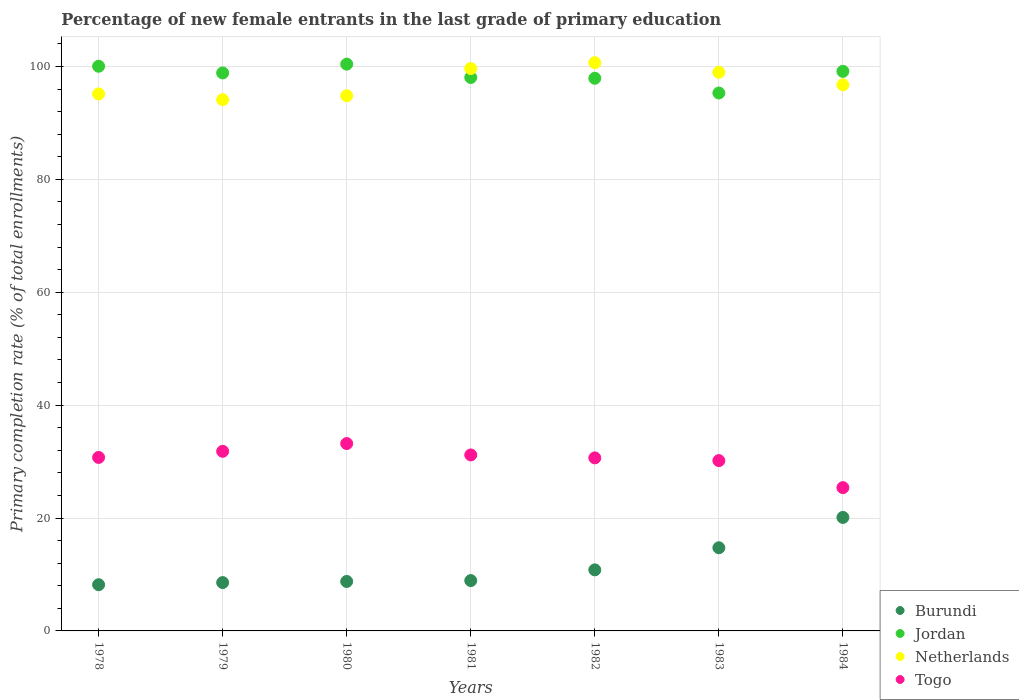What is the percentage of new female entrants in Togo in 1980?
Offer a very short reply. 33.19. Across all years, what is the maximum percentage of new female entrants in Jordan?
Your answer should be compact. 100.41. Across all years, what is the minimum percentage of new female entrants in Jordan?
Offer a terse response. 95.3. In which year was the percentage of new female entrants in Netherlands maximum?
Your answer should be compact. 1982. What is the total percentage of new female entrants in Netherlands in the graph?
Make the answer very short. 680.06. What is the difference between the percentage of new female entrants in Togo in 1978 and that in 1983?
Offer a terse response. 0.56. What is the difference between the percentage of new female entrants in Burundi in 1984 and the percentage of new female entrants in Netherlands in 1982?
Give a very brief answer. -80.56. What is the average percentage of new female entrants in Jordan per year?
Give a very brief answer. 98.53. In the year 1978, what is the difference between the percentage of new female entrants in Burundi and percentage of new female entrants in Jordan?
Your answer should be compact. -91.85. In how many years, is the percentage of new female entrants in Togo greater than 4 %?
Your answer should be very brief. 7. What is the ratio of the percentage of new female entrants in Burundi in 1979 to that in 1983?
Provide a succinct answer. 0.58. Is the difference between the percentage of new female entrants in Burundi in 1980 and 1983 greater than the difference between the percentage of new female entrants in Jordan in 1980 and 1983?
Your response must be concise. No. What is the difference between the highest and the second highest percentage of new female entrants in Netherlands?
Your answer should be compact. 1.04. What is the difference between the highest and the lowest percentage of new female entrants in Netherlands?
Your response must be concise. 6.56. In how many years, is the percentage of new female entrants in Jordan greater than the average percentage of new female entrants in Jordan taken over all years?
Your answer should be compact. 4. Is the sum of the percentage of new female entrants in Togo in 1981 and 1984 greater than the maximum percentage of new female entrants in Netherlands across all years?
Offer a terse response. No. Is the percentage of new female entrants in Netherlands strictly greater than the percentage of new female entrants in Togo over the years?
Offer a terse response. Yes. How many dotlines are there?
Your answer should be compact. 4. Are the values on the major ticks of Y-axis written in scientific E-notation?
Ensure brevity in your answer.  No. Does the graph contain any zero values?
Make the answer very short. No. Does the graph contain grids?
Give a very brief answer. Yes. Where does the legend appear in the graph?
Offer a very short reply. Bottom right. How many legend labels are there?
Provide a short and direct response. 4. What is the title of the graph?
Make the answer very short. Percentage of new female entrants in the last grade of primary education. What is the label or title of the X-axis?
Provide a succinct answer. Years. What is the label or title of the Y-axis?
Offer a terse response. Primary completion rate (% of total enrollments). What is the Primary completion rate (% of total enrollments) in Burundi in 1978?
Ensure brevity in your answer.  8.19. What is the Primary completion rate (% of total enrollments) of Jordan in 1978?
Make the answer very short. 100.04. What is the Primary completion rate (% of total enrollments) of Netherlands in 1978?
Keep it short and to the point. 95.13. What is the Primary completion rate (% of total enrollments) of Togo in 1978?
Your answer should be compact. 30.73. What is the Primary completion rate (% of total enrollments) in Burundi in 1979?
Offer a very short reply. 8.57. What is the Primary completion rate (% of total enrollments) of Jordan in 1979?
Make the answer very short. 98.85. What is the Primary completion rate (% of total enrollments) in Netherlands in 1979?
Offer a terse response. 94.11. What is the Primary completion rate (% of total enrollments) of Togo in 1979?
Your answer should be compact. 31.82. What is the Primary completion rate (% of total enrollments) in Burundi in 1980?
Make the answer very short. 8.76. What is the Primary completion rate (% of total enrollments) of Jordan in 1980?
Ensure brevity in your answer.  100.41. What is the Primary completion rate (% of total enrollments) of Netherlands in 1980?
Your answer should be compact. 94.81. What is the Primary completion rate (% of total enrollments) in Togo in 1980?
Make the answer very short. 33.19. What is the Primary completion rate (% of total enrollments) in Burundi in 1981?
Offer a very short reply. 8.92. What is the Primary completion rate (% of total enrollments) of Jordan in 1981?
Your answer should be compact. 98.05. What is the Primary completion rate (% of total enrollments) in Netherlands in 1981?
Keep it short and to the point. 99.63. What is the Primary completion rate (% of total enrollments) of Togo in 1981?
Provide a short and direct response. 31.18. What is the Primary completion rate (% of total enrollments) in Burundi in 1982?
Make the answer very short. 10.82. What is the Primary completion rate (% of total enrollments) in Jordan in 1982?
Your response must be concise. 97.91. What is the Primary completion rate (% of total enrollments) of Netherlands in 1982?
Provide a short and direct response. 100.67. What is the Primary completion rate (% of total enrollments) of Togo in 1982?
Your answer should be very brief. 30.66. What is the Primary completion rate (% of total enrollments) in Burundi in 1983?
Your response must be concise. 14.73. What is the Primary completion rate (% of total enrollments) of Jordan in 1983?
Ensure brevity in your answer.  95.3. What is the Primary completion rate (% of total enrollments) of Netherlands in 1983?
Keep it short and to the point. 98.96. What is the Primary completion rate (% of total enrollments) of Togo in 1983?
Keep it short and to the point. 30.17. What is the Primary completion rate (% of total enrollments) of Burundi in 1984?
Your answer should be very brief. 20.11. What is the Primary completion rate (% of total enrollments) of Jordan in 1984?
Provide a short and direct response. 99.13. What is the Primary completion rate (% of total enrollments) in Netherlands in 1984?
Ensure brevity in your answer.  96.75. What is the Primary completion rate (% of total enrollments) in Togo in 1984?
Make the answer very short. 25.39. Across all years, what is the maximum Primary completion rate (% of total enrollments) in Burundi?
Make the answer very short. 20.11. Across all years, what is the maximum Primary completion rate (% of total enrollments) of Jordan?
Provide a succinct answer. 100.41. Across all years, what is the maximum Primary completion rate (% of total enrollments) of Netherlands?
Make the answer very short. 100.67. Across all years, what is the maximum Primary completion rate (% of total enrollments) in Togo?
Your answer should be very brief. 33.19. Across all years, what is the minimum Primary completion rate (% of total enrollments) in Burundi?
Give a very brief answer. 8.19. Across all years, what is the minimum Primary completion rate (% of total enrollments) in Jordan?
Offer a terse response. 95.3. Across all years, what is the minimum Primary completion rate (% of total enrollments) of Netherlands?
Make the answer very short. 94.11. Across all years, what is the minimum Primary completion rate (% of total enrollments) in Togo?
Provide a short and direct response. 25.39. What is the total Primary completion rate (% of total enrollments) in Burundi in the graph?
Keep it short and to the point. 80.09. What is the total Primary completion rate (% of total enrollments) of Jordan in the graph?
Provide a short and direct response. 689.69. What is the total Primary completion rate (% of total enrollments) of Netherlands in the graph?
Ensure brevity in your answer.  680.06. What is the total Primary completion rate (% of total enrollments) of Togo in the graph?
Your answer should be compact. 213.14. What is the difference between the Primary completion rate (% of total enrollments) in Burundi in 1978 and that in 1979?
Make the answer very short. -0.38. What is the difference between the Primary completion rate (% of total enrollments) of Jordan in 1978 and that in 1979?
Your answer should be compact. 1.19. What is the difference between the Primary completion rate (% of total enrollments) in Netherlands in 1978 and that in 1979?
Keep it short and to the point. 1.02. What is the difference between the Primary completion rate (% of total enrollments) of Togo in 1978 and that in 1979?
Offer a terse response. -1.09. What is the difference between the Primary completion rate (% of total enrollments) of Burundi in 1978 and that in 1980?
Ensure brevity in your answer.  -0.58. What is the difference between the Primary completion rate (% of total enrollments) in Jordan in 1978 and that in 1980?
Provide a short and direct response. -0.37. What is the difference between the Primary completion rate (% of total enrollments) of Netherlands in 1978 and that in 1980?
Ensure brevity in your answer.  0.32. What is the difference between the Primary completion rate (% of total enrollments) of Togo in 1978 and that in 1980?
Give a very brief answer. -2.46. What is the difference between the Primary completion rate (% of total enrollments) in Burundi in 1978 and that in 1981?
Provide a short and direct response. -0.73. What is the difference between the Primary completion rate (% of total enrollments) in Jordan in 1978 and that in 1981?
Your response must be concise. 1.99. What is the difference between the Primary completion rate (% of total enrollments) of Netherlands in 1978 and that in 1981?
Offer a very short reply. -4.5. What is the difference between the Primary completion rate (% of total enrollments) of Togo in 1978 and that in 1981?
Provide a succinct answer. -0.44. What is the difference between the Primary completion rate (% of total enrollments) of Burundi in 1978 and that in 1982?
Your response must be concise. -2.63. What is the difference between the Primary completion rate (% of total enrollments) in Jordan in 1978 and that in 1982?
Ensure brevity in your answer.  2.13. What is the difference between the Primary completion rate (% of total enrollments) in Netherlands in 1978 and that in 1982?
Ensure brevity in your answer.  -5.54. What is the difference between the Primary completion rate (% of total enrollments) in Togo in 1978 and that in 1982?
Your answer should be very brief. 0.08. What is the difference between the Primary completion rate (% of total enrollments) in Burundi in 1978 and that in 1983?
Provide a succinct answer. -6.54. What is the difference between the Primary completion rate (% of total enrollments) of Jordan in 1978 and that in 1983?
Give a very brief answer. 4.74. What is the difference between the Primary completion rate (% of total enrollments) in Netherlands in 1978 and that in 1983?
Keep it short and to the point. -3.83. What is the difference between the Primary completion rate (% of total enrollments) of Togo in 1978 and that in 1983?
Your response must be concise. 0.56. What is the difference between the Primary completion rate (% of total enrollments) of Burundi in 1978 and that in 1984?
Keep it short and to the point. -11.92. What is the difference between the Primary completion rate (% of total enrollments) in Jordan in 1978 and that in 1984?
Offer a terse response. 0.9. What is the difference between the Primary completion rate (% of total enrollments) in Netherlands in 1978 and that in 1984?
Ensure brevity in your answer.  -1.62. What is the difference between the Primary completion rate (% of total enrollments) of Togo in 1978 and that in 1984?
Provide a succinct answer. 5.35. What is the difference between the Primary completion rate (% of total enrollments) in Burundi in 1979 and that in 1980?
Provide a succinct answer. -0.2. What is the difference between the Primary completion rate (% of total enrollments) in Jordan in 1979 and that in 1980?
Your answer should be very brief. -1.56. What is the difference between the Primary completion rate (% of total enrollments) of Netherlands in 1979 and that in 1980?
Offer a terse response. -0.7. What is the difference between the Primary completion rate (% of total enrollments) in Togo in 1979 and that in 1980?
Ensure brevity in your answer.  -1.37. What is the difference between the Primary completion rate (% of total enrollments) of Burundi in 1979 and that in 1981?
Keep it short and to the point. -0.35. What is the difference between the Primary completion rate (% of total enrollments) in Jordan in 1979 and that in 1981?
Make the answer very short. 0.81. What is the difference between the Primary completion rate (% of total enrollments) in Netherlands in 1979 and that in 1981?
Your answer should be compact. -5.52. What is the difference between the Primary completion rate (% of total enrollments) in Togo in 1979 and that in 1981?
Your answer should be compact. 0.64. What is the difference between the Primary completion rate (% of total enrollments) in Burundi in 1979 and that in 1982?
Keep it short and to the point. -2.25. What is the difference between the Primary completion rate (% of total enrollments) in Jordan in 1979 and that in 1982?
Give a very brief answer. 0.95. What is the difference between the Primary completion rate (% of total enrollments) in Netherlands in 1979 and that in 1982?
Ensure brevity in your answer.  -6.56. What is the difference between the Primary completion rate (% of total enrollments) of Togo in 1979 and that in 1982?
Offer a very short reply. 1.16. What is the difference between the Primary completion rate (% of total enrollments) in Burundi in 1979 and that in 1983?
Provide a short and direct response. -6.17. What is the difference between the Primary completion rate (% of total enrollments) in Jordan in 1979 and that in 1983?
Make the answer very short. 3.56. What is the difference between the Primary completion rate (% of total enrollments) in Netherlands in 1979 and that in 1983?
Provide a succinct answer. -4.85. What is the difference between the Primary completion rate (% of total enrollments) in Togo in 1979 and that in 1983?
Provide a succinct answer. 1.65. What is the difference between the Primary completion rate (% of total enrollments) in Burundi in 1979 and that in 1984?
Ensure brevity in your answer.  -11.54. What is the difference between the Primary completion rate (% of total enrollments) of Jordan in 1979 and that in 1984?
Offer a terse response. -0.28. What is the difference between the Primary completion rate (% of total enrollments) in Netherlands in 1979 and that in 1984?
Provide a succinct answer. -2.63. What is the difference between the Primary completion rate (% of total enrollments) of Togo in 1979 and that in 1984?
Offer a terse response. 6.44. What is the difference between the Primary completion rate (% of total enrollments) of Burundi in 1980 and that in 1981?
Keep it short and to the point. -0.15. What is the difference between the Primary completion rate (% of total enrollments) in Jordan in 1980 and that in 1981?
Ensure brevity in your answer.  2.37. What is the difference between the Primary completion rate (% of total enrollments) of Netherlands in 1980 and that in 1981?
Keep it short and to the point. -4.82. What is the difference between the Primary completion rate (% of total enrollments) of Togo in 1980 and that in 1981?
Your response must be concise. 2.02. What is the difference between the Primary completion rate (% of total enrollments) in Burundi in 1980 and that in 1982?
Give a very brief answer. -2.05. What is the difference between the Primary completion rate (% of total enrollments) in Jordan in 1980 and that in 1982?
Provide a short and direct response. 2.51. What is the difference between the Primary completion rate (% of total enrollments) in Netherlands in 1980 and that in 1982?
Ensure brevity in your answer.  -5.86. What is the difference between the Primary completion rate (% of total enrollments) in Togo in 1980 and that in 1982?
Offer a terse response. 2.54. What is the difference between the Primary completion rate (% of total enrollments) of Burundi in 1980 and that in 1983?
Ensure brevity in your answer.  -5.97. What is the difference between the Primary completion rate (% of total enrollments) in Jordan in 1980 and that in 1983?
Provide a succinct answer. 5.11. What is the difference between the Primary completion rate (% of total enrollments) of Netherlands in 1980 and that in 1983?
Your answer should be very brief. -4.15. What is the difference between the Primary completion rate (% of total enrollments) of Togo in 1980 and that in 1983?
Offer a terse response. 3.02. What is the difference between the Primary completion rate (% of total enrollments) in Burundi in 1980 and that in 1984?
Ensure brevity in your answer.  -11.34. What is the difference between the Primary completion rate (% of total enrollments) in Jordan in 1980 and that in 1984?
Provide a short and direct response. 1.28. What is the difference between the Primary completion rate (% of total enrollments) of Netherlands in 1980 and that in 1984?
Ensure brevity in your answer.  -1.93. What is the difference between the Primary completion rate (% of total enrollments) of Togo in 1980 and that in 1984?
Ensure brevity in your answer.  7.81. What is the difference between the Primary completion rate (% of total enrollments) of Burundi in 1981 and that in 1982?
Offer a very short reply. -1.9. What is the difference between the Primary completion rate (% of total enrollments) of Jordan in 1981 and that in 1982?
Offer a very short reply. 0.14. What is the difference between the Primary completion rate (% of total enrollments) in Netherlands in 1981 and that in 1982?
Offer a very short reply. -1.04. What is the difference between the Primary completion rate (% of total enrollments) of Togo in 1981 and that in 1982?
Your response must be concise. 0.52. What is the difference between the Primary completion rate (% of total enrollments) in Burundi in 1981 and that in 1983?
Your answer should be compact. -5.81. What is the difference between the Primary completion rate (% of total enrollments) of Jordan in 1981 and that in 1983?
Ensure brevity in your answer.  2.75. What is the difference between the Primary completion rate (% of total enrollments) in Netherlands in 1981 and that in 1983?
Give a very brief answer. 0.67. What is the difference between the Primary completion rate (% of total enrollments) of Togo in 1981 and that in 1983?
Provide a short and direct response. 1. What is the difference between the Primary completion rate (% of total enrollments) in Burundi in 1981 and that in 1984?
Your response must be concise. -11.19. What is the difference between the Primary completion rate (% of total enrollments) of Jordan in 1981 and that in 1984?
Ensure brevity in your answer.  -1.09. What is the difference between the Primary completion rate (% of total enrollments) in Netherlands in 1981 and that in 1984?
Your answer should be compact. 2.88. What is the difference between the Primary completion rate (% of total enrollments) in Togo in 1981 and that in 1984?
Provide a succinct answer. 5.79. What is the difference between the Primary completion rate (% of total enrollments) of Burundi in 1982 and that in 1983?
Make the answer very short. -3.91. What is the difference between the Primary completion rate (% of total enrollments) of Jordan in 1982 and that in 1983?
Ensure brevity in your answer.  2.61. What is the difference between the Primary completion rate (% of total enrollments) of Netherlands in 1982 and that in 1983?
Your answer should be compact. 1.71. What is the difference between the Primary completion rate (% of total enrollments) of Togo in 1982 and that in 1983?
Provide a short and direct response. 0.48. What is the difference between the Primary completion rate (% of total enrollments) in Burundi in 1982 and that in 1984?
Your answer should be very brief. -9.29. What is the difference between the Primary completion rate (% of total enrollments) of Jordan in 1982 and that in 1984?
Provide a short and direct response. -1.23. What is the difference between the Primary completion rate (% of total enrollments) in Netherlands in 1982 and that in 1984?
Ensure brevity in your answer.  3.93. What is the difference between the Primary completion rate (% of total enrollments) in Togo in 1982 and that in 1984?
Ensure brevity in your answer.  5.27. What is the difference between the Primary completion rate (% of total enrollments) of Burundi in 1983 and that in 1984?
Your answer should be compact. -5.37. What is the difference between the Primary completion rate (% of total enrollments) in Jordan in 1983 and that in 1984?
Your answer should be compact. -3.84. What is the difference between the Primary completion rate (% of total enrollments) of Netherlands in 1983 and that in 1984?
Make the answer very short. 2.22. What is the difference between the Primary completion rate (% of total enrollments) of Togo in 1983 and that in 1984?
Your response must be concise. 4.79. What is the difference between the Primary completion rate (% of total enrollments) in Burundi in 1978 and the Primary completion rate (% of total enrollments) in Jordan in 1979?
Your answer should be very brief. -90.67. What is the difference between the Primary completion rate (% of total enrollments) in Burundi in 1978 and the Primary completion rate (% of total enrollments) in Netherlands in 1979?
Offer a very short reply. -85.93. What is the difference between the Primary completion rate (% of total enrollments) of Burundi in 1978 and the Primary completion rate (% of total enrollments) of Togo in 1979?
Keep it short and to the point. -23.63. What is the difference between the Primary completion rate (% of total enrollments) in Jordan in 1978 and the Primary completion rate (% of total enrollments) in Netherlands in 1979?
Provide a succinct answer. 5.92. What is the difference between the Primary completion rate (% of total enrollments) of Jordan in 1978 and the Primary completion rate (% of total enrollments) of Togo in 1979?
Give a very brief answer. 68.22. What is the difference between the Primary completion rate (% of total enrollments) of Netherlands in 1978 and the Primary completion rate (% of total enrollments) of Togo in 1979?
Give a very brief answer. 63.31. What is the difference between the Primary completion rate (% of total enrollments) in Burundi in 1978 and the Primary completion rate (% of total enrollments) in Jordan in 1980?
Ensure brevity in your answer.  -92.23. What is the difference between the Primary completion rate (% of total enrollments) of Burundi in 1978 and the Primary completion rate (% of total enrollments) of Netherlands in 1980?
Make the answer very short. -86.62. What is the difference between the Primary completion rate (% of total enrollments) of Burundi in 1978 and the Primary completion rate (% of total enrollments) of Togo in 1980?
Your answer should be compact. -25.01. What is the difference between the Primary completion rate (% of total enrollments) in Jordan in 1978 and the Primary completion rate (% of total enrollments) in Netherlands in 1980?
Offer a very short reply. 5.23. What is the difference between the Primary completion rate (% of total enrollments) in Jordan in 1978 and the Primary completion rate (% of total enrollments) in Togo in 1980?
Ensure brevity in your answer.  66.84. What is the difference between the Primary completion rate (% of total enrollments) of Netherlands in 1978 and the Primary completion rate (% of total enrollments) of Togo in 1980?
Ensure brevity in your answer.  61.94. What is the difference between the Primary completion rate (% of total enrollments) in Burundi in 1978 and the Primary completion rate (% of total enrollments) in Jordan in 1981?
Your response must be concise. -89.86. What is the difference between the Primary completion rate (% of total enrollments) of Burundi in 1978 and the Primary completion rate (% of total enrollments) of Netherlands in 1981?
Give a very brief answer. -91.44. What is the difference between the Primary completion rate (% of total enrollments) in Burundi in 1978 and the Primary completion rate (% of total enrollments) in Togo in 1981?
Provide a short and direct response. -22.99. What is the difference between the Primary completion rate (% of total enrollments) in Jordan in 1978 and the Primary completion rate (% of total enrollments) in Netherlands in 1981?
Provide a succinct answer. 0.41. What is the difference between the Primary completion rate (% of total enrollments) in Jordan in 1978 and the Primary completion rate (% of total enrollments) in Togo in 1981?
Your answer should be compact. 68.86. What is the difference between the Primary completion rate (% of total enrollments) of Netherlands in 1978 and the Primary completion rate (% of total enrollments) of Togo in 1981?
Your response must be concise. 63.95. What is the difference between the Primary completion rate (% of total enrollments) in Burundi in 1978 and the Primary completion rate (% of total enrollments) in Jordan in 1982?
Ensure brevity in your answer.  -89.72. What is the difference between the Primary completion rate (% of total enrollments) of Burundi in 1978 and the Primary completion rate (% of total enrollments) of Netherlands in 1982?
Keep it short and to the point. -92.48. What is the difference between the Primary completion rate (% of total enrollments) in Burundi in 1978 and the Primary completion rate (% of total enrollments) in Togo in 1982?
Keep it short and to the point. -22.47. What is the difference between the Primary completion rate (% of total enrollments) of Jordan in 1978 and the Primary completion rate (% of total enrollments) of Netherlands in 1982?
Provide a succinct answer. -0.63. What is the difference between the Primary completion rate (% of total enrollments) of Jordan in 1978 and the Primary completion rate (% of total enrollments) of Togo in 1982?
Offer a terse response. 69.38. What is the difference between the Primary completion rate (% of total enrollments) in Netherlands in 1978 and the Primary completion rate (% of total enrollments) in Togo in 1982?
Your answer should be compact. 64.47. What is the difference between the Primary completion rate (% of total enrollments) in Burundi in 1978 and the Primary completion rate (% of total enrollments) in Jordan in 1983?
Your response must be concise. -87.11. What is the difference between the Primary completion rate (% of total enrollments) in Burundi in 1978 and the Primary completion rate (% of total enrollments) in Netherlands in 1983?
Provide a short and direct response. -90.78. What is the difference between the Primary completion rate (% of total enrollments) in Burundi in 1978 and the Primary completion rate (% of total enrollments) in Togo in 1983?
Give a very brief answer. -21.99. What is the difference between the Primary completion rate (% of total enrollments) in Jordan in 1978 and the Primary completion rate (% of total enrollments) in Netherlands in 1983?
Your response must be concise. 1.07. What is the difference between the Primary completion rate (% of total enrollments) of Jordan in 1978 and the Primary completion rate (% of total enrollments) of Togo in 1983?
Your response must be concise. 69.86. What is the difference between the Primary completion rate (% of total enrollments) in Netherlands in 1978 and the Primary completion rate (% of total enrollments) in Togo in 1983?
Provide a short and direct response. 64.96. What is the difference between the Primary completion rate (% of total enrollments) of Burundi in 1978 and the Primary completion rate (% of total enrollments) of Jordan in 1984?
Your answer should be compact. -90.95. What is the difference between the Primary completion rate (% of total enrollments) of Burundi in 1978 and the Primary completion rate (% of total enrollments) of Netherlands in 1984?
Offer a terse response. -88.56. What is the difference between the Primary completion rate (% of total enrollments) in Burundi in 1978 and the Primary completion rate (% of total enrollments) in Togo in 1984?
Give a very brief answer. -17.2. What is the difference between the Primary completion rate (% of total enrollments) in Jordan in 1978 and the Primary completion rate (% of total enrollments) in Netherlands in 1984?
Your response must be concise. 3.29. What is the difference between the Primary completion rate (% of total enrollments) of Jordan in 1978 and the Primary completion rate (% of total enrollments) of Togo in 1984?
Your response must be concise. 74.65. What is the difference between the Primary completion rate (% of total enrollments) in Netherlands in 1978 and the Primary completion rate (% of total enrollments) in Togo in 1984?
Keep it short and to the point. 69.74. What is the difference between the Primary completion rate (% of total enrollments) in Burundi in 1979 and the Primary completion rate (% of total enrollments) in Jordan in 1980?
Your answer should be compact. -91.85. What is the difference between the Primary completion rate (% of total enrollments) of Burundi in 1979 and the Primary completion rate (% of total enrollments) of Netherlands in 1980?
Ensure brevity in your answer.  -86.25. What is the difference between the Primary completion rate (% of total enrollments) in Burundi in 1979 and the Primary completion rate (% of total enrollments) in Togo in 1980?
Offer a terse response. -24.63. What is the difference between the Primary completion rate (% of total enrollments) in Jordan in 1979 and the Primary completion rate (% of total enrollments) in Netherlands in 1980?
Ensure brevity in your answer.  4.04. What is the difference between the Primary completion rate (% of total enrollments) of Jordan in 1979 and the Primary completion rate (% of total enrollments) of Togo in 1980?
Offer a terse response. 65.66. What is the difference between the Primary completion rate (% of total enrollments) of Netherlands in 1979 and the Primary completion rate (% of total enrollments) of Togo in 1980?
Your answer should be very brief. 60.92. What is the difference between the Primary completion rate (% of total enrollments) in Burundi in 1979 and the Primary completion rate (% of total enrollments) in Jordan in 1981?
Provide a short and direct response. -89.48. What is the difference between the Primary completion rate (% of total enrollments) of Burundi in 1979 and the Primary completion rate (% of total enrollments) of Netherlands in 1981?
Provide a short and direct response. -91.06. What is the difference between the Primary completion rate (% of total enrollments) of Burundi in 1979 and the Primary completion rate (% of total enrollments) of Togo in 1981?
Make the answer very short. -22.61. What is the difference between the Primary completion rate (% of total enrollments) of Jordan in 1979 and the Primary completion rate (% of total enrollments) of Netherlands in 1981?
Offer a very short reply. -0.78. What is the difference between the Primary completion rate (% of total enrollments) in Jordan in 1979 and the Primary completion rate (% of total enrollments) in Togo in 1981?
Make the answer very short. 67.68. What is the difference between the Primary completion rate (% of total enrollments) of Netherlands in 1979 and the Primary completion rate (% of total enrollments) of Togo in 1981?
Provide a succinct answer. 62.94. What is the difference between the Primary completion rate (% of total enrollments) in Burundi in 1979 and the Primary completion rate (% of total enrollments) in Jordan in 1982?
Keep it short and to the point. -89.34. What is the difference between the Primary completion rate (% of total enrollments) in Burundi in 1979 and the Primary completion rate (% of total enrollments) in Netherlands in 1982?
Keep it short and to the point. -92.11. What is the difference between the Primary completion rate (% of total enrollments) in Burundi in 1979 and the Primary completion rate (% of total enrollments) in Togo in 1982?
Make the answer very short. -22.09. What is the difference between the Primary completion rate (% of total enrollments) in Jordan in 1979 and the Primary completion rate (% of total enrollments) in Netherlands in 1982?
Keep it short and to the point. -1.82. What is the difference between the Primary completion rate (% of total enrollments) in Jordan in 1979 and the Primary completion rate (% of total enrollments) in Togo in 1982?
Ensure brevity in your answer.  68.2. What is the difference between the Primary completion rate (% of total enrollments) in Netherlands in 1979 and the Primary completion rate (% of total enrollments) in Togo in 1982?
Make the answer very short. 63.46. What is the difference between the Primary completion rate (% of total enrollments) of Burundi in 1979 and the Primary completion rate (% of total enrollments) of Jordan in 1983?
Ensure brevity in your answer.  -86.73. What is the difference between the Primary completion rate (% of total enrollments) of Burundi in 1979 and the Primary completion rate (% of total enrollments) of Netherlands in 1983?
Ensure brevity in your answer.  -90.4. What is the difference between the Primary completion rate (% of total enrollments) of Burundi in 1979 and the Primary completion rate (% of total enrollments) of Togo in 1983?
Offer a terse response. -21.61. What is the difference between the Primary completion rate (% of total enrollments) of Jordan in 1979 and the Primary completion rate (% of total enrollments) of Netherlands in 1983?
Your response must be concise. -0.11. What is the difference between the Primary completion rate (% of total enrollments) in Jordan in 1979 and the Primary completion rate (% of total enrollments) in Togo in 1983?
Provide a succinct answer. 68.68. What is the difference between the Primary completion rate (% of total enrollments) of Netherlands in 1979 and the Primary completion rate (% of total enrollments) of Togo in 1983?
Make the answer very short. 63.94. What is the difference between the Primary completion rate (% of total enrollments) of Burundi in 1979 and the Primary completion rate (% of total enrollments) of Jordan in 1984?
Offer a very short reply. -90.57. What is the difference between the Primary completion rate (% of total enrollments) in Burundi in 1979 and the Primary completion rate (% of total enrollments) in Netherlands in 1984?
Provide a short and direct response. -88.18. What is the difference between the Primary completion rate (% of total enrollments) of Burundi in 1979 and the Primary completion rate (% of total enrollments) of Togo in 1984?
Provide a short and direct response. -16.82. What is the difference between the Primary completion rate (% of total enrollments) of Jordan in 1979 and the Primary completion rate (% of total enrollments) of Netherlands in 1984?
Offer a very short reply. 2.11. What is the difference between the Primary completion rate (% of total enrollments) of Jordan in 1979 and the Primary completion rate (% of total enrollments) of Togo in 1984?
Offer a terse response. 73.47. What is the difference between the Primary completion rate (% of total enrollments) in Netherlands in 1979 and the Primary completion rate (% of total enrollments) in Togo in 1984?
Offer a terse response. 68.73. What is the difference between the Primary completion rate (% of total enrollments) in Burundi in 1980 and the Primary completion rate (% of total enrollments) in Jordan in 1981?
Ensure brevity in your answer.  -89.28. What is the difference between the Primary completion rate (% of total enrollments) in Burundi in 1980 and the Primary completion rate (% of total enrollments) in Netherlands in 1981?
Offer a very short reply. -90.87. What is the difference between the Primary completion rate (% of total enrollments) of Burundi in 1980 and the Primary completion rate (% of total enrollments) of Togo in 1981?
Your answer should be compact. -22.41. What is the difference between the Primary completion rate (% of total enrollments) in Jordan in 1980 and the Primary completion rate (% of total enrollments) in Netherlands in 1981?
Your answer should be very brief. 0.78. What is the difference between the Primary completion rate (% of total enrollments) of Jordan in 1980 and the Primary completion rate (% of total enrollments) of Togo in 1981?
Offer a very short reply. 69.24. What is the difference between the Primary completion rate (% of total enrollments) of Netherlands in 1980 and the Primary completion rate (% of total enrollments) of Togo in 1981?
Offer a very short reply. 63.64. What is the difference between the Primary completion rate (% of total enrollments) of Burundi in 1980 and the Primary completion rate (% of total enrollments) of Jordan in 1982?
Give a very brief answer. -89.14. What is the difference between the Primary completion rate (% of total enrollments) of Burundi in 1980 and the Primary completion rate (% of total enrollments) of Netherlands in 1982?
Give a very brief answer. -91.91. What is the difference between the Primary completion rate (% of total enrollments) of Burundi in 1980 and the Primary completion rate (% of total enrollments) of Togo in 1982?
Make the answer very short. -21.89. What is the difference between the Primary completion rate (% of total enrollments) of Jordan in 1980 and the Primary completion rate (% of total enrollments) of Netherlands in 1982?
Make the answer very short. -0.26. What is the difference between the Primary completion rate (% of total enrollments) in Jordan in 1980 and the Primary completion rate (% of total enrollments) in Togo in 1982?
Provide a succinct answer. 69.76. What is the difference between the Primary completion rate (% of total enrollments) in Netherlands in 1980 and the Primary completion rate (% of total enrollments) in Togo in 1982?
Offer a very short reply. 64.16. What is the difference between the Primary completion rate (% of total enrollments) of Burundi in 1980 and the Primary completion rate (% of total enrollments) of Jordan in 1983?
Make the answer very short. -86.53. What is the difference between the Primary completion rate (% of total enrollments) of Burundi in 1980 and the Primary completion rate (% of total enrollments) of Netherlands in 1983?
Provide a succinct answer. -90.2. What is the difference between the Primary completion rate (% of total enrollments) in Burundi in 1980 and the Primary completion rate (% of total enrollments) in Togo in 1983?
Provide a succinct answer. -21.41. What is the difference between the Primary completion rate (% of total enrollments) of Jordan in 1980 and the Primary completion rate (% of total enrollments) of Netherlands in 1983?
Keep it short and to the point. 1.45. What is the difference between the Primary completion rate (% of total enrollments) in Jordan in 1980 and the Primary completion rate (% of total enrollments) in Togo in 1983?
Offer a very short reply. 70.24. What is the difference between the Primary completion rate (% of total enrollments) in Netherlands in 1980 and the Primary completion rate (% of total enrollments) in Togo in 1983?
Offer a very short reply. 64.64. What is the difference between the Primary completion rate (% of total enrollments) of Burundi in 1980 and the Primary completion rate (% of total enrollments) of Jordan in 1984?
Your response must be concise. -90.37. What is the difference between the Primary completion rate (% of total enrollments) in Burundi in 1980 and the Primary completion rate (% of total enrollments) in Netherlands in 1984?
Offer a terse response. -87.98. What is the difference between the Primary completion rate (% of total enrollments) in Burundi in 1980 and the Primary completion rate (% of total enrollments) in Togo in 1984?
Offer a very short reply. -16.62. What is the difference between the Primary completion rate (% of total enrollments) of Jordan in 1980 and the Primary completion rate (% of total enrollments) of Netherlands in 1984?
Your response must be concise. 3.67. What is the difference between the Primary completion rate (% of total enrollments) in Jordan in 1980 and the Primary completion rate (% of total enrollments) in Togo in 1984?
Provide a short and direct response. 75.03. What is the difference between the Primary completion rate (% of total enrollments) of Netherlands in 1980 and the Primary completion rate (% of total enrollments) of Togo in 1984?
Provide a short and direct response. 69.43. What is the difference between the Primary completion rate (% of total enrollments) in Burundi in 1981 and the Primary completion rate (% of total enrollments) in Jordan in 1982?
Offer a very short reply. -88.99. What is the difference between the Primary completion rate (% of total enrollments) of Burundi in 1981 and the Primary completion rate (% of total enrollments) of Netherlands in 1982?
Keep it short and to the point. -91.75. What is the difference between the Primary completion rate (% of total enrollments) in Burundi in 1981 and the Primary completion rate (% of total enrollments) in Togo in 1982?
Offer a terse response. -21.74. What is the difference between the Primary completion rate (% of total enrollments) of Jordan in 1981 and the Primary completion rate (% of total enrollments) of Netherlands in 1982?
Ensure brevity in your answer.  -2.62. What is the difference between the Primary completion rate (% of total enrollments) of Jordan in 1981 and the Primary completion rate (% of total enrollments) of Togo in 1982?
Your response must be concise. 67.39. What is the difference between the Primary completion rate (% of total enrollments) of Netherlands in 1981 and the Primary completion rate (% of total enrollments) of Togo in 1982?
Provide a short and direct response. 68.97. What is the difference between the Primary completion rate (% of total enrollments) in Burundi in 1981 and the Primary completion rate (% of total enrollments) in Jordan in 1983?
Your answer should be very brief. -86.38. What is the difference between the Primary completion rate (% of total enrollments) of Burundi in 1981 and the Primary completion rate (% of total enrollments) of Netherlands in 1983?
Provide a short and direct response. -90.05. What is the difference between the Primary completion rate (% of total enrollments) in Burundi in 1981 and the Primary completion rate (% of total enrollments) in Togo in 1983?
Provide a succinct answer. -21.26. What is the difference between the Primary completion rate (% of total enrollments) in Jordan in 1981 and the Primary completion rate (% of total enrollments) in Netherlands in 1983?
Offer a very short reply. -0.92. What is the difference between the Primary completion rate (% of total enrollments) in Jordan in 1981 and the Primary completion rate (% of total enrollments) in Togo in 1983?
Your answer should be compact. 67.87. What is the difference between the Primary completion rate (% of total enrollments) in Netherlands in 1981 and the Primary completion rate (% of total enrollments) in Togo in 1983?
Give a very brief answer. 69.46. What is the difference between the Primary completion rate (% of total enrollments) in Burundi in 1981 and the Primary completion rate (% of total enrollments) in Jordan in 1984?
Offer a terse response. -90.22. What is the difference between the Primary completion rate (% of total enrollments) in Burundi in 1981 and the Primary completion rate (% of total enrollments) in Netherlands in 1984?
Your answer should be very brief. -87.83. What is the difference between the Primary completion rate (% of total enrollments) of Burundi in 1981 and the Primary completion rate (% of total enrollments) of Togo in 1984?
Your answer should be compact. -16.47. What is the difference between the Primary completion rate (% of total enrollments) of Jordan in 1981 and the Primary completion rate (% of total enrollments) of Netherlands in 1984?
Keep it short and to the point. 1.3. What is the difference between the Primary completion rate (% of total enrollments) of Jordan in 1981 and the Primary completion rate (% of total enrollments) of Togo in 1984?
Provide a succinct answer. 72.66. What is the difference between the Primary completion rate (% of total enrollments) of Netherlands in 1981 and the Primary completion rate (% of total enrollments) of Togo in 1984?
Your answer should be very brief. 74.24. What is the difference between the Primary completion rate (% of total enrollments) in Burundi in 1982 and the Primary completion rate (% of total enrollments) in Jordan in 1983?
Your response must be concise. -84.48. What is the difference between the Primary completion rate (% of total enrollments) of Burundi in 1982 and the Primary completion rate (% of total enrollments) of Netherlands in 1983?
Make the answer very short. -88.15. What is the difference between the Primary completion rate (% of total enrollments) of Burundi in 1982 and the Primary completion rate (% of total enrollments) of Togo in 1983?
Give a very brief answer. -19.36. What is the difference between the Primary completion rate (% of total enrollments) of Jordan in 1982 and the Primary completion rate (% of total enrollments) of Netherlands in 1983?
Make the answer very short. -1.06. What is the difference between the Primary completion rate (% of total enrollments) in Jordan in 1982 and the Primary completion rate (% of total enrollments) in Togo in 1983?
Your response must be concise. 67.73. What is the difference between the Primary completion rate (% of total enrollments) of Netherlands in 1982 and the Primary completion rate (% of total enrollments) of Togo in 1983?
Offer a very short reply. 70.5. What is the difference between the Primary completion rate (% of total enrollments) in Burundi in 1982 and the Primary completion rate (% of total enrollments) in Jordan in 1984?
Make the answer very short. -88.32. What is the difference between the Primary completion rate (% of total enrollments) of Burundi in 1982 and the Primary completion rate (% of total enrollments) of Netherlands in 1984?
Your response must be concise. -85.93. What is the difference between the Primary completion rate (% of total enrollments) in Burundi in 1982 and the Primary completion rate (% of total enrollments) in Togo in 1984?
Provide a succinct answer. -14.57. What is the difference between the Primary completion rate (% of total enrollments) in Jordan in 1982 and the Primary completion rate (% of total enrollments) in Netherlands in 1984?
Ensure brevity in your answer.  1.16. What is the difference between the Primary completion rate (% of total enrollments) in Jordan in 1982 and the Primary completion rate (% of total enrollments) in Togo in 1984?
Offer a terse response. 72.52. What is the difference between the Primary completion rate (% of total enrollments) of Netherlands in 1982 and the Primary completion rate (% of total enrollments) of Togo in 1984?
Your answer should be compact. 75.29. What is the difference between the Primary completion rate (% of total enrollments) in Burundi in 1983 and the Primary completion rate (% of total enrollments) in Jordan in 1984?
Offer a terse response. -84.4. What is the difference between the Primary completion rate (% of total enrollments) in Burundi in 1983 and the Primary completion rate (% of total enrollments) in Netherlands in 1984?
Keep it short and to the point. -82.01. What is the difference between the Primary completion rate (% of total enrollments) in Burundi in 1983 and the Primary completion rate (% of total enrollments) in Togo in 1984?
Your answer should be very brief. -10.65. What is the difference between the Primary completion rate (% of total enrollments) of Jordan in 1983 and the Primary completion rate (% of total enrollments) of Netherlands in 1984?
Offer a very short reply. -1.45. What is the difference between the Primary completion rate (% of total enrollments) of Jordan in 1983 and the Primary completion rate (% of total enrollments) of Togo in 1984?
Offer a very short reply. 69.91. What is the difference between the Primary completion rate (% of total enrollments) of Netherlands in 1983 and the Primary completion rate (% of total enrollments) of Togo in 1984?
Give a very brief answer. 73.58. What is the average Primary completion rate (% of total enrollments) of Burundi per year?
Keep it short and to the point. 11.44. What is the average Primary completion rate (% of total enrollments) in Jordan per year?
Your answer should be compact. 98.53. What is the average Primary completion rate (% of total enrollments) of Netherlands per year?
Provide a short and direct response. 97.15. What is the average Primary completion rate (% of total enrollments) of Togo per year?
Make the answer very short. 30.45. In the year 1978, what is the difference between the Primary completion rate (% of total enrollments) of Burundi and Primary completion rate (% of total enrollments) of Jordan?
Your response must be concise. -91.85. In the year 1978, what is the difference between the Primary completion rate (% of total enrollments) of Burundi and Primary completion rate (% of total enrollments) of Netherlands?
Make the answer very short. -86.94. In the year 1978, what is the difference between the Primary completion rate (% of total enrollments) in Burundi and Primary completion rate (% of total enrollments) in Togo?
Offer a very short reply. -22.55. In the year 1978, what is the difference between the Primary completion rate (% of total enrollments) of Jordan and Primary completion rate (% of total enrollments) of Netherlands?
Your answer should be compact. 4.91. In the year 1978, what is the difference between the Primary completion rate (% of total enrollments) of Jordan and Primary completion rate (% of total enrollments) of Togo?
Your answer should be very brief. 69.3. In the year 1978, what is the difference between the Primary completion rate (% of total enrollments) in Netherlands and Primary completion rate (% of total enrollments) in Togo?
Your response must be concise. 64.4. In the year 1979, what is the difference between the Primary completion rate (% of total enrollments) in Burundi and Primary completion rate (% of total enrollments) in Jordan?
Ensure brevity in your answer.  -90.29. In the year 1979, what is the difference between the Primary completion rate (% of total enrollments) of Burundi and Primary completion rate (% of total enrollments) of Netherlands?
Offer a very short reply. -85.55. In the year 1979, what is the difference between the Primary completion rate (% of total enrollments) of Burundi and Primary completion rate (% of total enrollments) of Togo?
Make the answer very short. -23.26. In the year 1979, what is the difference between the Primary completion rate (% of total enrollments) in Jordan and Primary completion rate (% of total enrollments) in Netherlands?
Your answer should be compact. 4.74. In the year 1979, what is the difference between the Primary completion rate (% of total enrollments) of Jordan and Primary completion rate (% of total enrollments) of Togo?
Offer a very short reply. 67.03. In the year 1979, what is the difference between the Primary completion rate (% of total enrollments) of Netherlands and Primary completion rate (% of total enrollments) of Togo?
Offer a very short reply. 62.29. In the year 1980, what is the difference between the Primary completion rate (% of total enrollments) of Burundi and Primary completion rate (% of total enrollments) of Jordan?
Your response must be concise. -91.65. In the year 1980, what is the difference between the Primary completion rate (% of total enrollments) in Burundi and Primary completion rate (% of total enrollments) in Netherlands?
Offer a very short reply. -86.05. In the year 1980, what is the difference between the Primary completion rate (% of total enrollments) of Burundi and Primary completion rate (% of total enrollments) of Togo?
Your answer should be compact. -24.43. In the year 1980, what is the difference between the Primary completion rate (% of total enrollments) in Jordan and Primary completion rate (% of total enrollments) in Netherlands?
Give a very brief answer. 5.6. In the year 1980, what is the difference between the Primary completion rate (% of total enrollments) in Jordan and Primary completion rate (% of total enrollments) in Togo?
Offer a very short reply. 67.22. In the year 1980, what is the difference between the Primary completion rate (% of total enrollments) in Netherlands and Primary completion rate (% of total enrollments) in Togo?
Provide a succinct answer. 61.62. In the year 1981, what is the difference between the Primary completion rate (% of total enrollments) in Burundi and Primary completion rate (% of total enrollments) in Jordan?
Offer a very short reply. -89.13. In the year 1981, what is the difference between the Primary completion rate (% of total enrollments) of Burundi and Primary completion rate (% of total enrollments) of Netherlands?
Offer a very short reply. -90.71. In the year 1981, what is the difference between the Primary completion rate (% of total enrollments) in Burundi and Primary completion rate (% of total enrollments) in Togo?
Your answer should be compact. -22.26. In the year 1981, what is the difference between the Primary completion rate (% of total enrollments) of Jordan and Primary completion rate (% of total enrollments) of Netherlands?
Ensure brevity in your answer.  -1.58. In the year 1981, what is the difference between the Primary completion rate (% of total enrollments) in Jordan and Primary completion rate (% of total enrollments) in Togo?
Keep it short and to the point. 66.87. In the year 1981, what is the difference between the Primary completion rate (% of total enrollments) in Netherlands and Primary completion rate (% of total enrollments) in Togo?
Offer a very short reply. 68.45. In the year 1982, what is the difference between the Primary completion rate (% of total enrollments) in Burundi and Primary completion rate (% of total enrollments) in Jordan?
Provide a short and direct response. -87.09. In the year 1982, what is the difference between the Primary completion rate (% of total enrollments) of Burundi and Primary completion rate (% of total enrollments) of Netherlands?
Your response must be concise. -89.85. In the year 1982, what is the difference between the Primary completion rate (% of total enrollments) in Burundi and Primary completion rate (% of total enrollments) in Togo?
Give a very brief answer. -19.84. In the year 1982, what is the difference between the Primary completion rate (% of total enrollments) of Jordan and Primary completion rate (% of total enrollments) of Netherlands?
Your answer should be compact. -2.76. In the year 1982, what is the difference between the Primary completion rate (% of total enrollments) of Jordan and Primary completion rate (% of total enrollments) of Togo?
Make the answer very short. 67.25. In the year 1982, what is the difference between the Primary completion rate (% of total enrollments) in Netherlands and Primary completion rate (% of total enrollments) in Togo?
Your response must be concise. 70.01. In the year 1983, what is the difference between the Primary completion rate (% of total enrollments) in Burundi and Primary completion rate (% of total enrollments) in Jordan?
Provide a succinct answer. -80.57. In the year 1983, what is the difference between the Primary completion rate (% of total enrollments) of Burundi and Primary completion rate (% of total enrollments) of Netherlands?
Your answer should be very brief. -84.23. In the year 1983, what is the difference between the Primary completion rate (% of total enrollments) of Burundi and Primary completion rate (% of total enrollments) of Togo?
Your response must be concise. -15.44. In the year 1983, what is the difference between the Primary completion rate (% of total enrollments) in Jordan and Primary completion rate (% of total enrollments) in Netherlands?
Keep it short and to the point. -3.67. In the year 1983, what is the difference between the Primary completion rate (% of total enrollments) in Jordan and Primary completion rate (% of total enrollments) in Togo?
Ensure brevity in your answer.  65.12. In the year 1983, what is the difference between the Primary completion rate (% of total enrollments) of Netherlands and Primary completion rate (% of total enrollments) of Togo?
Your response must be concise. 68.79. In the year 1984, what is the difference between the Primary completion rate (% of total enrollments) in Burundi and Primary completion rate (% of total enrollments) in Jordan?
Make the answer very short. -79.03. In the year 1984, what is the difference between the Primary completion rate (% of total enrollments) in Burundi and Primary completion rate (% of total enrollments) in Netherlands?
Give a very brief answer. -76.64. In the year 1984, what is the difference between the Primary completion rate (% of total enrollments) in Burundi and Primary completion rate (% of total enrollments) in Togo?
Keep it short and to the point. -5.28. In the year 1984, what is the difference between the Primary completion rate (% of total enrollments) of Jordan and Primary completion rate (% of total enrollments) of Netherlands?
Ensure brevity in your answer.  2.39. In the year 1984, what is the difference between the Primary completion rate (% of total enrollments) in Jordan and Primary completion rate (% of total enrollments) in Togo?
Keep it short and to the point. 73.75. In the year 1984, what is the difference between the Primary completion rate (% of total enrollments) of Netherlands and Primary completion rate (% of total enrollments) of Togo?
Offer a very short reply. 71.36. What is the ratio of the Primary completion rate (% of total enrollments) of Burundi in 1978 to that in 1979?
Provide a succinct answer. 0.96. What is the ratio of the Primary completion rate (% of total enrollments) of Netherlands in 1978 to that in 1979?
Your answer should be very brief. 1.01. What is the ratio of the Primary completion rate (% of total enrollments) in Togo in 1978 to that in 1979?
Your answer should be very brief. 0.97. What is the ratio of the Primary completion rate (% of total enrollments) of Burundi in 1978 to that in 1980?
Your answer should be compact. 0.93. What is the ratio of the Primary completion rate (% of total enrollments) of Jordan in 1978 to that in 1980?
Provide a succinct answer. 1. What is the ratio of the Primary completion rate (% of total enrollments) of Togo in 1978 to that in 1980?
Make the answer very short. 0.93. What is the ratio of the Primary completion rate (% of total enrollments) in Burundi in 1978 to that in 1981?
Provide a succinct answer. 0.92. What is the ratio of the Primary completion rate (% of total enrollments) in Jordan in 1978 to that in 1981?
Your answer should be compact. 1.02. What is the ratio of the Primary completion rate (% of total enrollments) of Netherlands in 1978 to that in 1981?
Keep it short and to the point. 0.95. What is the ratio of the Primary completion rate (% of total enrollments) in Togo in 1978 to that in 1981?
Keep it short and to the point. 0.99. What is the ratio of the Primary completion rate (% of total enrollments) in Burundi in 1978 to that in 1982?
Offer a very short reply. 0.76. What is the ratio of the Primary completion rate (% of total enrollments) of Jordan in 1978 to that in 1982?
Your answer should be compact. 1.02. What is the ratio of the Primary completion rate (% of total enrollments) in Netherlands in 1978 to that in 1982?
Provide a short and direct response. 0.94. What is the ratio of the Primary completion rate (% of total enrollments) in Togo in 1978 to that in 1982?
Keep it short and to the point. 1. What is the ratio of the Primary completion rate (% of total enrollments) in Burundi in 1978 to that in 1983?
Offer a terse response. 0.56. What is the ratio of the Primary completion rate (% of total enrollments) in Jordan in 1978 to that in 1983?
Your answer should be compact. 1.05. What is the ratio of the Primary completion rate (% of total enrollments) in Netherlands in 1978 to that in 1983?
Provide a short and direct response. 0.96. What is the ratio of the Primary completion rate (% of total enrollments) of Togo in 1978 to that in 1983?
Ensure brevity in your answer.  1.02. What is the ratio of the Primary completion rate (% of total enrollments) in Burundi in 1978 to that in 1984?
Offer a very short reply. 0.41. What is the ratio of the Primary completion rate (% of total enrollments) of Jordan in 1978 to that in 1984?
Your answer should be compact. 1.01. What is the ratio of the Primary completion rate (% of total enrollments) in Netherlands in 1978 to that in 1984?
Offer a terse response. 0.98. What is the ratio of the Primary completion rate (% of total enrollments) in Togo in 1978 to that in 1984?
Your response must be concise. 1.21. What is the ratio of the Primary completion rate (% of total enrollments) in Burundi in 1979 to that in 1980?
Provide a short and direct response. 0.98. What is the ratio of the Primary completion rate (% of total enrollments) of Jordan in 1979 to that in 1980?
Offer a very short reply. 0.98. What is the ratio of the Primary completion rate (% of total enrollments) in Togo in 1979 to that in 1980?
Ensure brevity in your answer.  0.96. What is the ratio of the Primary completion rate (% of total enrollments) of Burundi in 1979 to that in 1981?
Your answer should be compact. 0.96. What is the ratio of the Primary completion rate (% of total enrollments) of Jordan in 1979 to that in 1981?
Provide a short and direct response. 1.01. What is the ratio of the Primary completion rate (% of total enrollments) in Netherlands in 1979 to that in 1981?
Your answer should be compact. 0.94. What is the ratio of the Primary completion rate (% of total enrollments) of Togo in 1979 to that in 1981?
Keep it short and to the point. 1.02. What is the ratio of the Primary completion rate (% of total enrollments) of Burundi in 1979 to that in 1982?
Provide a succinct answer. 0.79. What is the ratio of the Primary completion rate (% of total enrollments) in Jordan in 1979 to that in 1982?
Your response must be concise. 1.01. What is the ratio of the Primary completion rate (% of total enrollments) of Netherlands in 1979 to that in 1982?
Your response must be concise. 0.93. What is the ratio of the Primary completion rate (% of total enrollments) of Togo in 1979 to that in 1982?
Provide a short and direct response. 1.04. What is the ratio of the Primary completion rate (% of total enrollments) of Burundi in 1979 to that in 1983?
Offer a very short reply. 0.58. What is the ratio of the Primary completion rate (% of total enrollments) in Jordan in 1979 to that in 1983?
Give a very brief answer. 1.04. What is the ratio of the Primary completion rate (% of total enrollments) in Netherlands in 1979 to that in 1983?
Your answer should be very brief. 0.95. What is the ratio of the Primary completion rate (% of total enrollments) in Togo in 1979 to that in 1983?
Provide a succinct answer. 1.05. What is the ratio of the Primary completion rate (% of total enrollments) of Burundi in 1979 to that in 1984?
Keep it short and to the point. 0.43. What is the ratio of the Primary completion rate (% of total enrollments) in Jordan in 1979 to that in 1984?
Your response must be concise. 1. What is the ratio of the Primary completion rate (% of total enrollments) in Netherlands in 1979 to that in 1984?
Provide a short and direct response. 0.97. What is the ratio of the Primary completion rate (% of total enrollments) in Togo in 1979 to that in 1984?
Give a very brief answer. 1.25. What is the ratio of the Primary completion rate (% of total enrollments) in Burundi in 1980 to that in 1981?
Offer a very short reply. 0.98. What is the ratio of the Primary completion rate (% of total enrollments) in Jordan in 1980 to that in 1981?
Keep it short and to the point. 1.02. What is the ratio of the Primary completion rate (% of total enrollments) in Netherlands in 1980 to that in 1981?
Offer a terse response. 0.95. What is the ratio of the Primary completion rate (% of total enrollments) in Togo in 1980 to that in 1981?
Provide a short and direct response. 1.06. What is the ratio of the Primary completion rate (% of total enrollments) of Burundi in 1980 to that in 1982?
Make the answer very short. 0.81. What is the ratio of the Primary completion rate (% of total enrollments) of Jordan in 1980 to that in 1982?
Your response must be concise. 1.03. What is the ratio of the Primary completion rate (% of total enrollments) of Netherlands in 1980 to that in 1982?
Keep it short and to the point. 0.94. What is the ratio of the Primary completion rate (% of total enrollments) in Togo in 1980 to that in 1982?
Offer a terse response. 1.08. What is the ratio of the Primary completion rate (% of total enrollments) of Burundi in 1980 to that in 1983?
Provide a short and direct response. 0.59. What is the ratio of the Primary completion rate (% of total enrollments) of Jordan in 1980 to that in 1983?
Provide a short and direct response. 1.05. What is the ratio of the Primary completion rate (% of total enrollments) of Netherlands in 1980 to that in 1983?
Give a very brief answer. 0.96. What is the ratio of the Primary completion rate (% of total enrollments) in Togo in 1980 to that in 1983?
Offer a terse response. 1.1. What is the ratio of the Primary completion rate (% of total enrollments) of Burundi in 1980 to that in 1984?
Ensure brevity in your answer.  0.44. What is the ratio of the Primary completion rate (% of total enrollments) in Jordan in 1980 to that in 1984?
Keep it short and to the point. 1.01. What is the ratio of the Primary completion rate (% of total enrollments) in Netherlands in 1980 to that in 1984?
Provide a succinct answer. 0.98. What is the ratio of the Primary completion rate (% of total enrollments) of Togo in 1980 to that in 1984?
Offer a terse response. 1.31. What is the ratio of the Primary completion rate (% of total enrollments) in Burundi in 1981 to that in 1982?
Offer a very short reply. 0.82. What is the ratio of the Primary completion rate (% of total enrollments) of Togo in 1981 to that in 1982?
Offer a very short reply. 1.02. What is the ratio of the Primary completion rate (% of total enrollments) of Burundi in 1981 to that in 1983?
Your answer should be compact. 0.61. What is the ratio of the Primary completion rate (% of total enrollments) of Jordan in 1981 to that in 1983?
Provide a short and direct response. 1.03. What is the ratio of the Primary completion rate (% of total enrollments) in Burundi in 1981 to that in 1984?
Your answer should be compact. 0.44. What is the ratio of the Primary completion rate (% of total enrollments) in Netherlands in 1981 to that in 1984?
Provide a succinct answer. 1.03. What is the ratio of the Primary completion rate (% of total enrollments) in Togo in 1981 to that in 1984?
Your response must be concise. 1.23. What is the ratio of the Primary completion rate (% of total enrollments) in Burundi in 1982 to that in 1983?
Provide a short and direct response. 0.73. What is the ratio of the Primary completion rate (% of total enrollments) in Jordan in 1982 to that in 1983?
Provide a succinct answer. 1.03. What is the ratio of the Primary completion rate (% of total enrollments) of Netherlands in 1982 to that in 1983?
Your response must be concise. 1.02. What is the ratio of the Primary completion rate (% of total enrollments) of Togo in 1982 to that in 1983?
Ensure brevity in your answer.  1.02. What is the ratio of the Primary completion rate (% of total enrollments) of Burundi in 1982 to that in 1984?
Provide a short and direct response. 0.54. What is the ratio of the Primary completion rate (% of total enrollments) of Jordan in 1982 to that in 1984?
Offer a terse response. 0.99. What is the ratio of the Primary completion rate (% of total enrollments) of Netherlands in 1982 to that in 1984?
Provide a succinct answer. 1.04. What is the ratio of the Primary completion rate (% of total enrollments) of Togo in 1982 to that in 1984?
Your response must be concise. 1.21. What is the ratio of the Primary completion rate (% of total enrollments) of Burundi in 1983 to that in 1984?
Provide a short and direct response. 0.73. What is the ratio of the Primary completion rate (% of total enrollments) of Jordan in 1983 to that in 1984?
Give a very brief answer. 0.96. What is the ratio of the Primary completion rate (% of total enrollments) in Netherlands in 1983 to that in 1984?
Keep it short and to the point. 1.02. What is the ratio of the Primary completion rate (% of total enrollments) in Togo in 1983 to that in 1984?
Keep it short and to the point. 1.19. What is the difference between the highest and the second highest Primary completion rate (% of total enrollments) in Burundi?
Offer a terse response. 5.37. What is the difference between the highest and the second highest Primary completion rate (% of total enrollments) of Jordan?
Your answer should be compact. 0.37. What is the difference between the highest and the second highest Primary completion rate (% of total enrollments) of Netherlands?
Offer a terse response. 1.04. What is the difference between the highest and the second highest Primary completion rate (% of total enrollments) of Togo?
Offer a terse response. 1.37. What is the difference between the highest and the lowest Primary completion rate (% of total enrollments) in Burundi?
Keep it short and to the point. 11.92. What is the difference between the highest and the lowest Primary completion rate (% of total enrollments) of Jordan?
Your answer should be very brief. 5.11. What is the difference between the highest and the lowest Primary completion rate (% of total enrollments) in Netherlands?
Offer a terse response. 6.56. What is the difference between the highest and the lowest Primary completion rate (% of total enrollments) of Togo?
Provide a succinct answer. 7.81. 